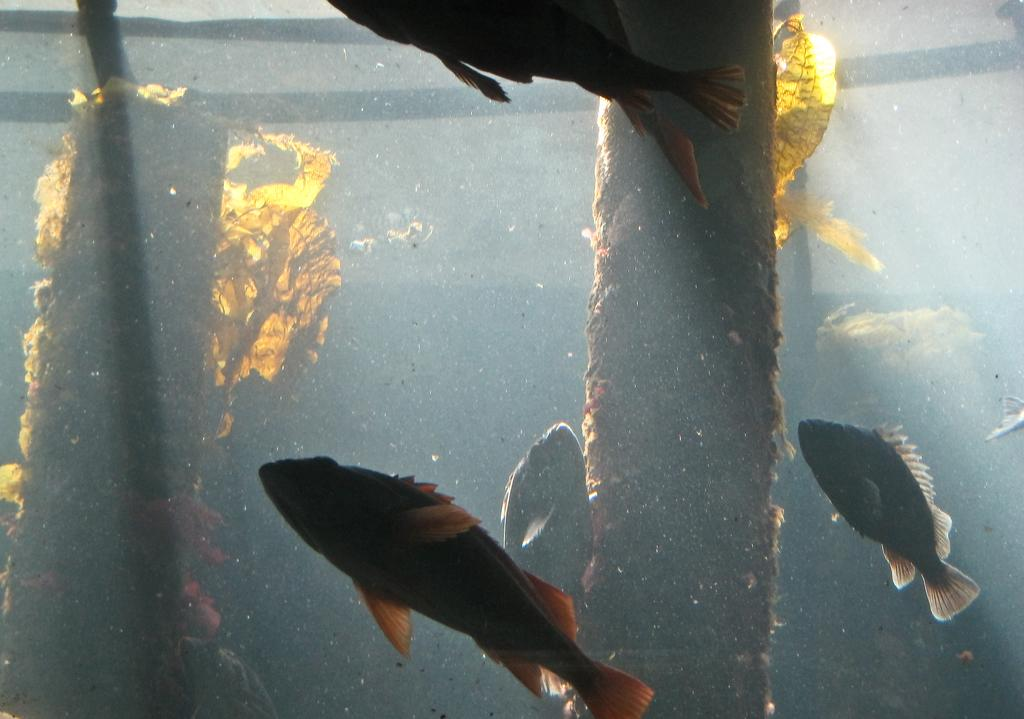What type of animals can be seen in the image? There are fishes in the image. What can be observed about the environment in the image? There are tree trunks in the water in the image. How many toes can be seen on the farmer's foot in the image? There is no farmer or foot present in the image; it features fishes and tree trunks in the water. 